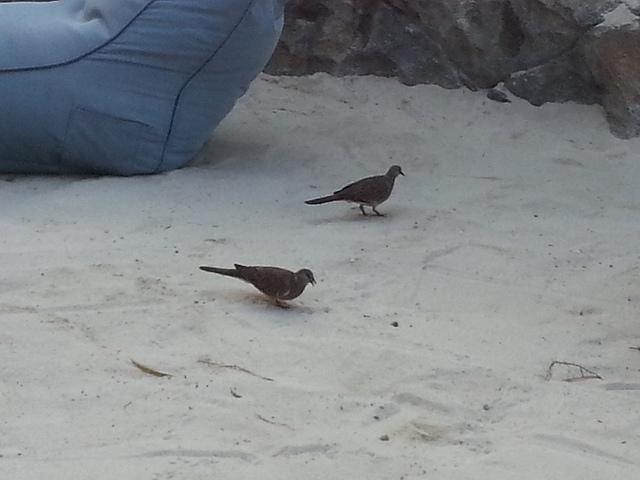How many birds are there?
Write a very short answer. 2. Are the birds eating?
Concise answer only. Yes. What are the birds walking on?
Write a very short answer. Sand. Is the structure to the left man-made?
Answer briefly. Yes. 